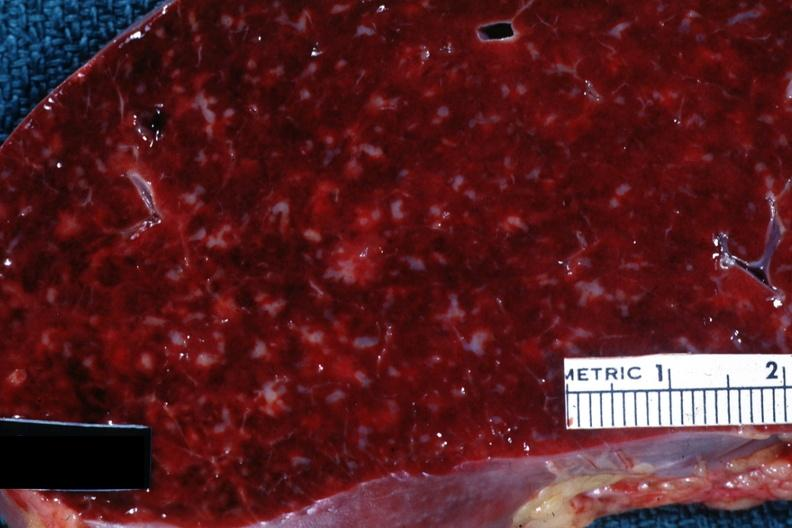s spleen present?
Answer the question using a single word or phrase. Yes 